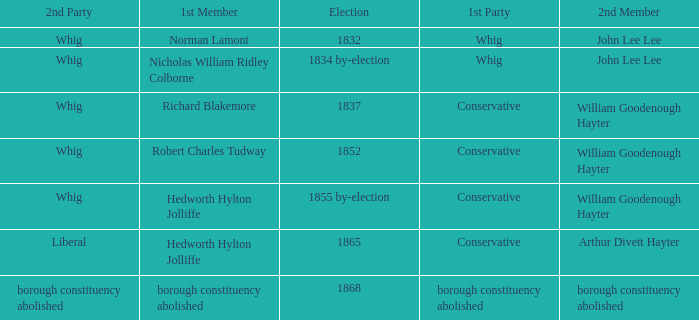What's the party of 2nd member arthur divett hayter when the 1st party is conservative? Liberal. 